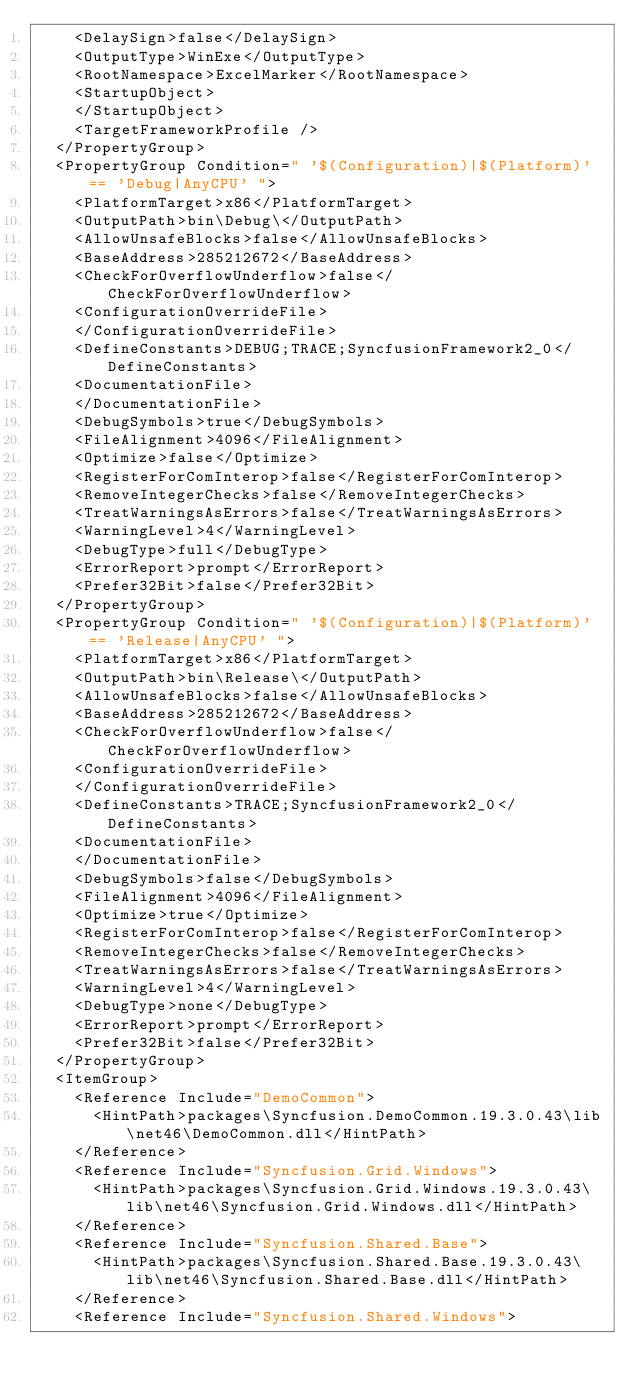Convert code to text. <code><loc_0><loc_0><loc_500><loc_500><_XML_>    <DelaySign>false</DelaySign>
    <OutputType>WinExe</OutputType>
    <RootNamespace>ExcelMarker</RootNamespace>
    <StartupObject>
    </StartupObject>
    <TargetFrameworkProfile />
  </PropertyGroup>
  <PropertyGroup Condition=" '$(Configuration)|$(Platform)' == 'Debug|AnyCPU' ">
    <PlatformTarget>x86</PlatformTarget>
    <OutputPath>bin\Debug\</OutputPath>
    <AllowUnsafeBlocks>false</AllowUnsafeBlocks>
    <BaseAddress>285212672</BaseAddress>
    <CheckForOverflowUnderflow>false</CheckForOverflowUnderflow>
    <ConfigurationOverrideFile>
    </ConfigurationOverrideFile>
    <DefineConstants>DEBUG;TRACE;SyncfusionFramework2_0</DefineConstants>
    <DocumentationFile>
    </DocumentationFile>
    <DebugSymbols>true</DebugSymbols>
    <FileAlignment>4096</FileAlignment>
    <Optimize>false</Optimize>
    <RegisterForComInterop>false</RegisterForComInterop>
    <RemoveIntegerChecks>false</RemoveIntegerChecks>
    <TreatWarningsAsErrors>false</TreatWarningsAsErrors>
    <WarningLevel>4</WarningLevel>
    <DebugType>full</DebugType>
    <ErrorReport>prompt</ErrorReport>
    <Prefer32Bit>false</Prefer32Bit>
  </PropertyGroup>
  <PropertyGroup Condition=" '$(Configuration)|$(Platform)' == 'Release|AnyCPU' ">
    <PlatformTarget>x86</PlatformTarget>
    <OutputPath>bin\Release\</OutputPath>
    <AllowUnsafeBlocks>false</AllowUnsafeBlocks>
    <BaseAddress>285212672</BaseAddress>
    <CheckForOverflowUnderflow>false</CheckForOverflowUnderflow>
    <ConfigurationOverrideFile>
    </ConfigurationOverrideFile>
    <DefineConstants>TRACE;SyncfusionFramework2_0</DefineConstants>
    <DocumentationFile>
    </DocumentationFile>
    <DebugSymbols>false</DebugSymbols>
    <FileAlignment>4096</FileAlignment>
    <Optimize>true</Optimize>
    <RegisterForComInterop>false</RegisterForComInterop>
    <RemoveIntegerChecks>false</RemoveIntegerChecks>
    <TreatWarningsAsErrors>false</TreatWarningsAsErrors>
    <WarningLevel>4</WarningLevel>
    <DebugType>none</DebugType>
    <ErrorReport>prompt</ErrorReport>
    <Prefer32Bit>false</Prefer32Bit>
  </PropertyGroup>
  <ItemGroup>
    <Reference Include="DemoCommon">
      <HintPath>packages\Syncfusion.DemoCommon.19.3.0.43\lib\net46\DemoCommon.dll</HintPath>
    </Reference>
    <Reference Include="Syncfusion.Grid.Windows">
      <HintPath>packages\Syncfusion.Grid.Windows.19.3.0.43\lib\net46\Syncfusion.Grid.Windows.dll</HintPath>
    </Reference>
    <Reference Include="Syncfusion.Shared.Base">
      <HintPath>packages\Syncfusion.Shared.Base.19.3.0.43\lib\net46\Syncfusion.Shared.Base.dll</HintPath>
    </Reference>
    <Reference Include="Syncfusion.Shared.Windows"></code> 